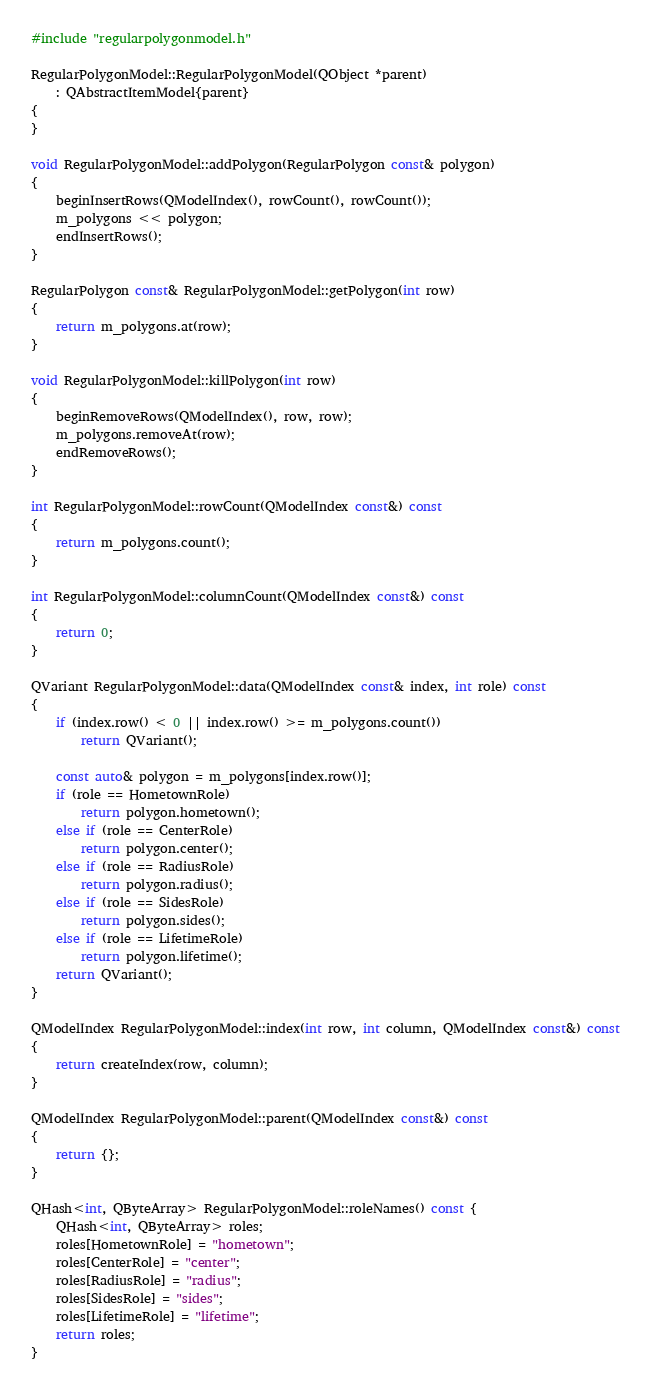Convert code to text. <code><loc_0><loc_0><loc_500><loc_500><_C++_>#include "regularpolygonmodel.h"

RegularPolygonModel::RegularPolygonModel(QObject *parent)
    : QAbstractItemModel{parent}
{
}

void RegularPolygonModel::addPolygon(RegularPolygon const& polygon)
{
    beginInsertRows(QModelIndex(), rowCount(), rowCount());
    m_polygons << polygon;
    endInsertRows();
}

RegularPolygon const& RegularPolygonModel::getPolygon(int row)
{
    return m_polygons.at(row);
}

void RegularPolygonModel::killPolygon(int row)
{
    beginRemoveRows(QModelIndex(), row, row);
    m_polygons.removeAt(row);
    endRemoveRows();
}

int RegularPolygonModel::rowCount(QModelIndex const&) const
{
    return m_polygons.count();
}

int RegularPolygonModel::columnCount(QModelIndex const&) const
{
    return 0;
}

QVariant RegularPolygonModel::data(QModelIndex const& index, int role) const
{
    if (index.row() < 0 || index.row() >= m_polygons.count())
        return QVariant();

    const auto& polygon = m_polygons[index.row()];
    if (role == HometownRole)
        return polygon.hometown();
    else if (role == CenterRole)
        return polygon.center();
    else if (role == RadiusRole)
        return polygon.radius();
    else if (role == SidesRole)
        return polygon.sides();
    else if (role == LifetimeRole)
        return polygon.lifetime();
    return QVariant();
}

QModelIndex RegularPolygonModel::index(int row, int column, QModelIndex const&) const
{
    return createIndex(row, column);
}

QModelIndex RegularPolygonModel::parent(QModelIndex const&) const
{
    return {};
}

QHash<int, QByteArray> RegularPolygonModel::roleNames() const {
    QHash<int, QByteArray> roles;
    roles[HometownRole] = "hometown";
    roles[CenterRole] = "center";
    roles[RadiusRole] = "radius";
    roles[SidesRole] = "sides";
    roles[LifetimeRole] = "lifetime";
    return roles;
}
</code> 